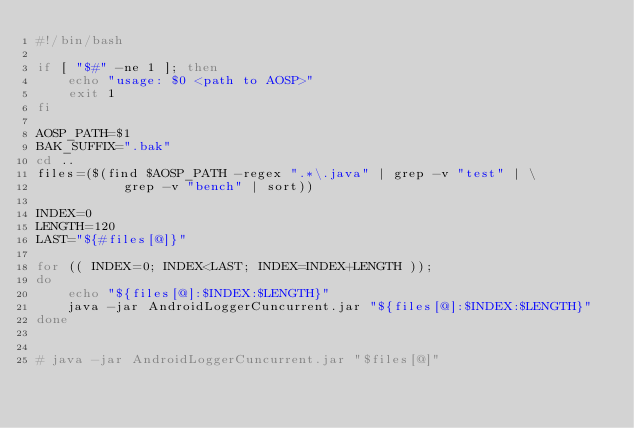<code> <loc_0><loc_0><loc_500><loc_500><_Bash_>#!/bin/bash

if [ "$#" -ne 1 ]; then
    echo "usage: $0 <path to AOSP>"
    exit 1
fi

AOSP_PATH=$1
BAK_SUFFIX=".bak"
cd ..
files=($(find $AOSP_PATH -regex ".*\.java" | grep -v "test" | \
	       grep -v "bench" | sort))

INDEX=0
LENGTH=120
LAST="${#files[@]}"

for (( INDEX=0; INDEX<LAST; INDEX=INDEX+LENGTH ));
do
    echo "${files[@]:$INDEX:$LENGTH}"
    java -jar AndroidLoggerCuncurrent.jar "${files[@]:$INDEX:$LENGTH}"
done


# java -jar AndroidLoggerCuncurrent.jar "$files[@]"
</code> 